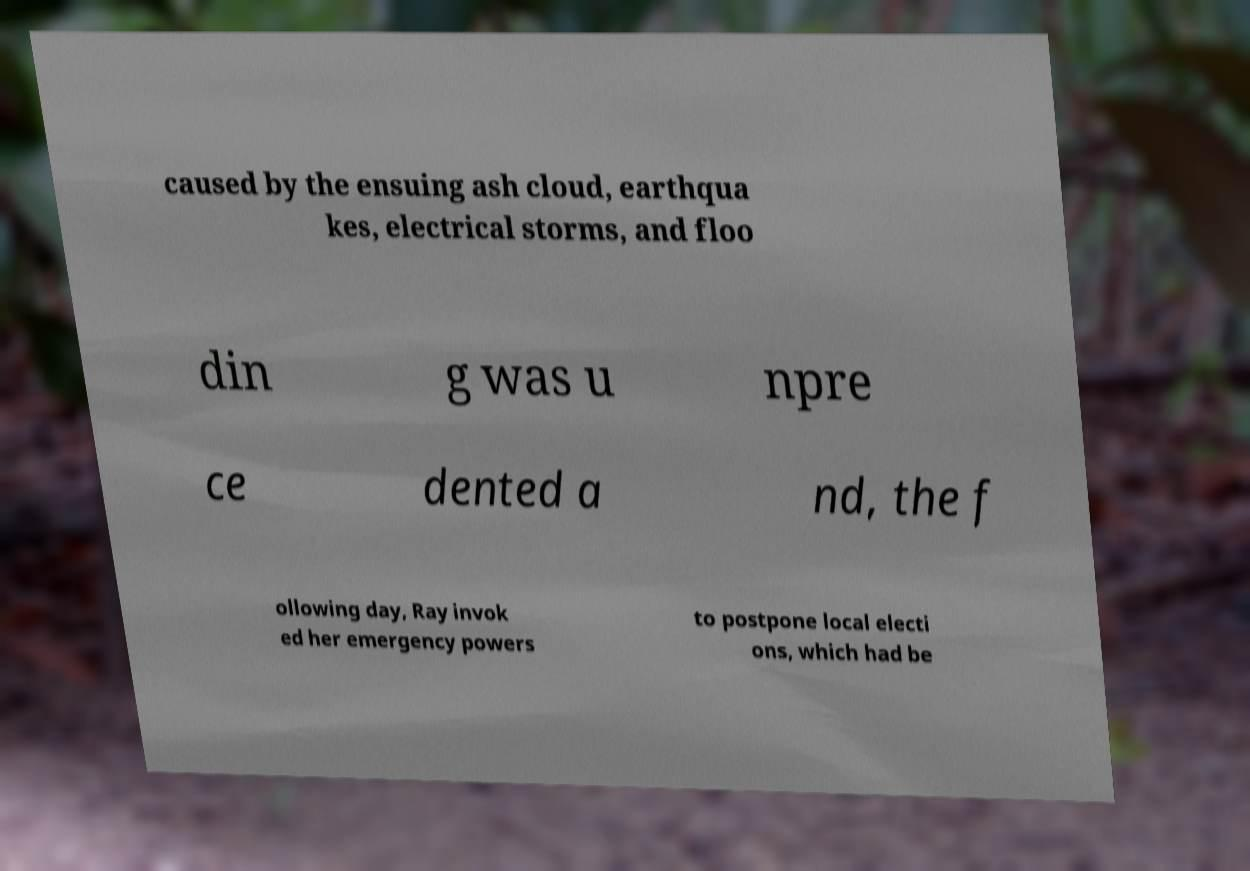Could you extract and type out the text from this image? caused by the ensuing ash cloud, earthqua kes, electrical storms, and floo din g was u npre ce dented a nd, the f ollowing day, Ray invok ed her emergency powers to postpone local electi ons, which had be 